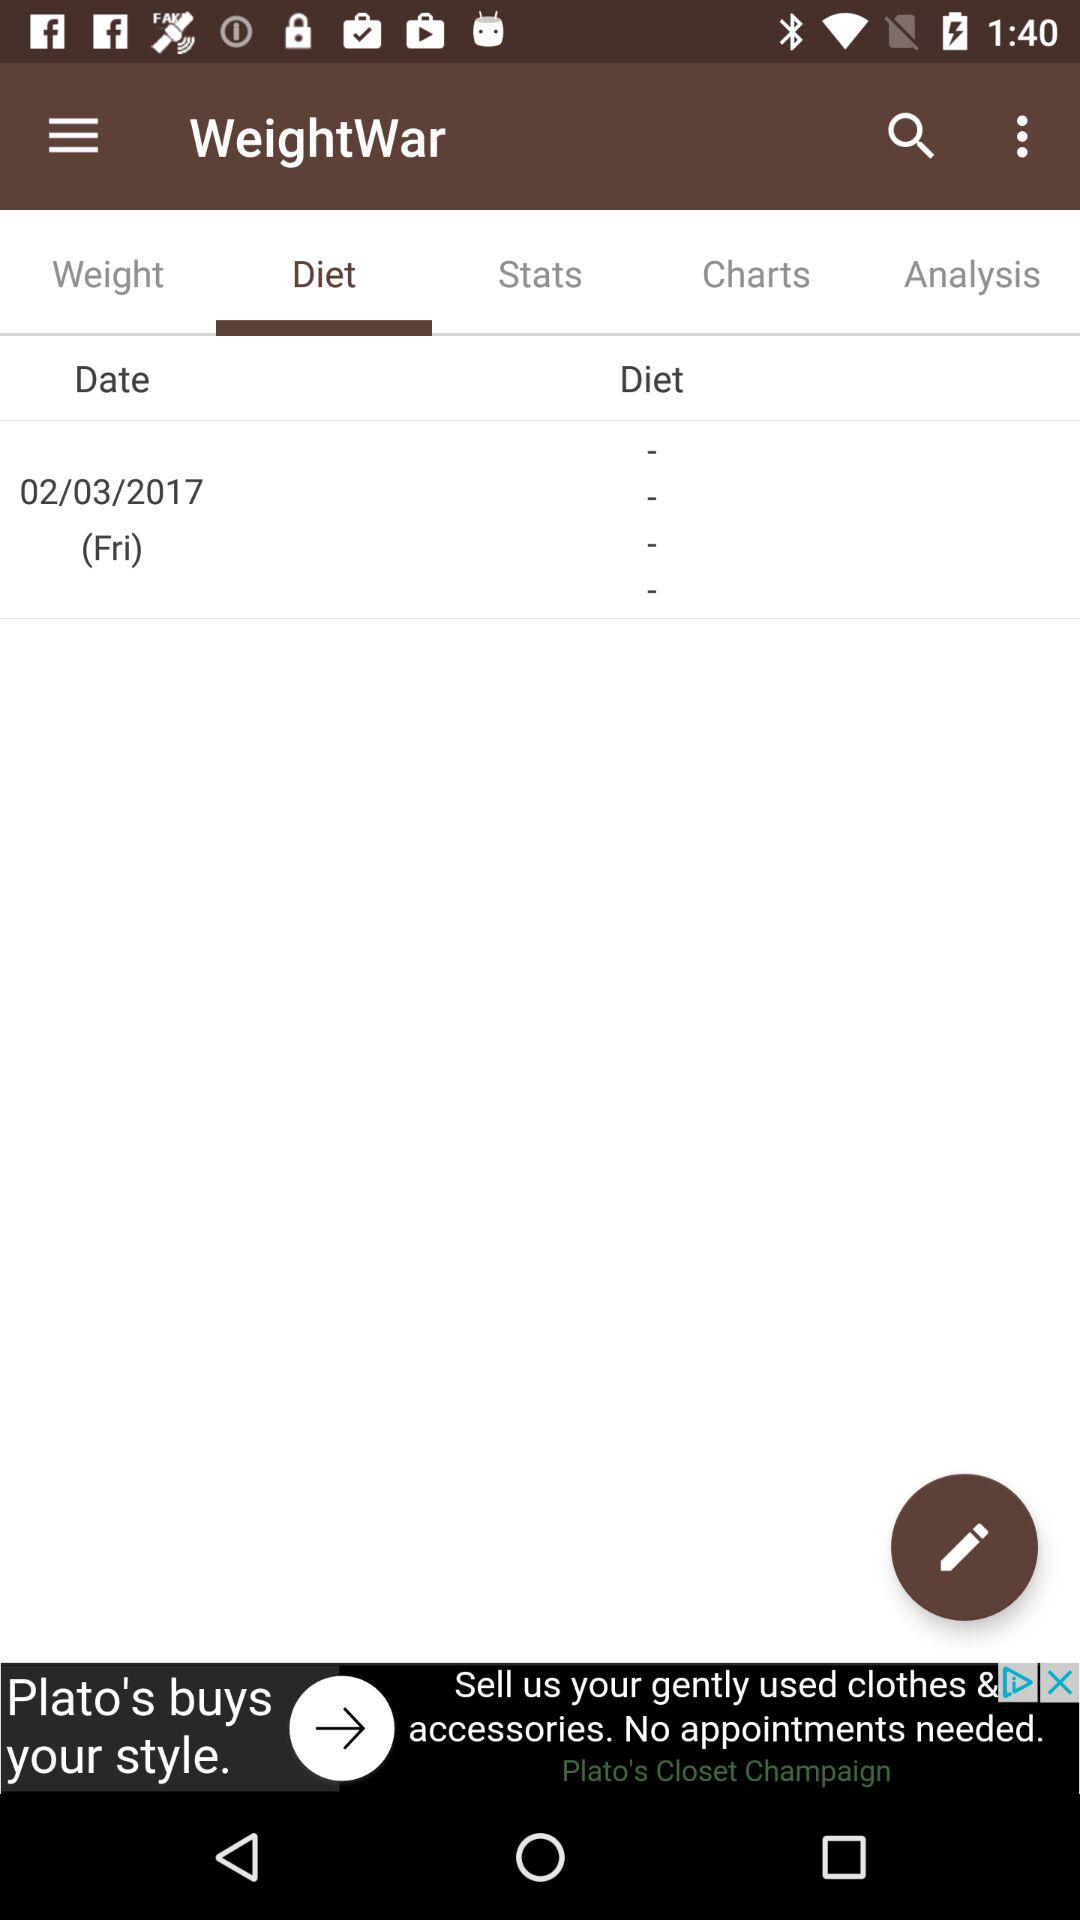What's the recorded date of the diet? The recorded date is Friday, February 3, 2017. 